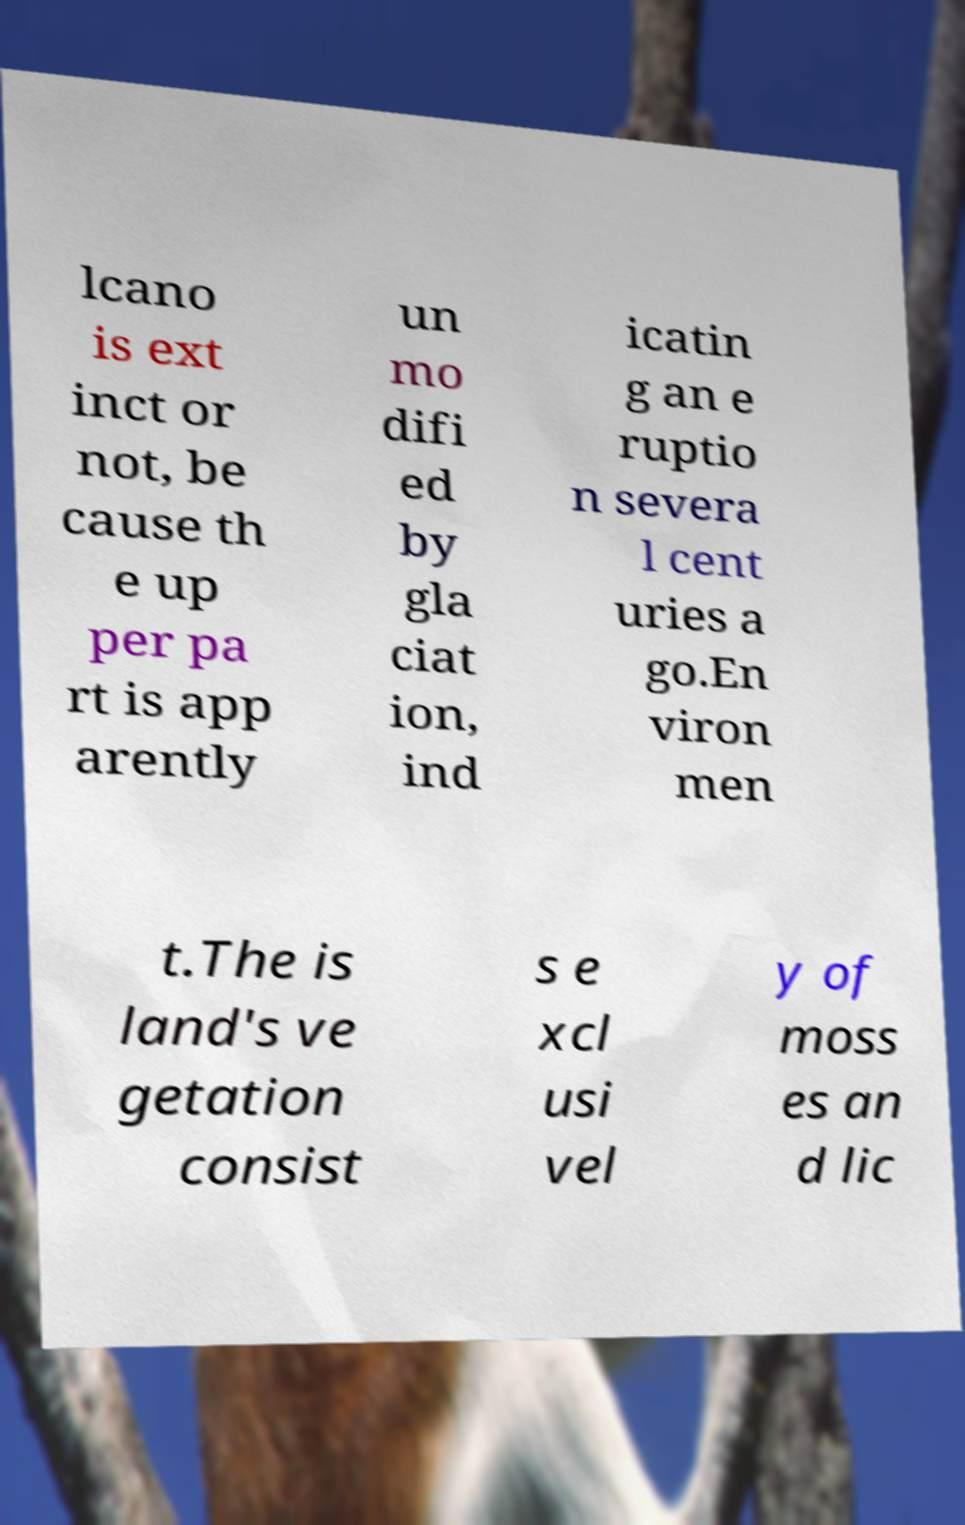Could you extract and type out the text from this image? lcano is ext inct or not, be cause th e up per pa rt is app arently un mo difi ed by gla ciat ion, ind icatin g an e ruptio n severa l cent uries a go.En viron men t.The is land's ve getation consist s e xcl usi vel y of moss es an d lic 